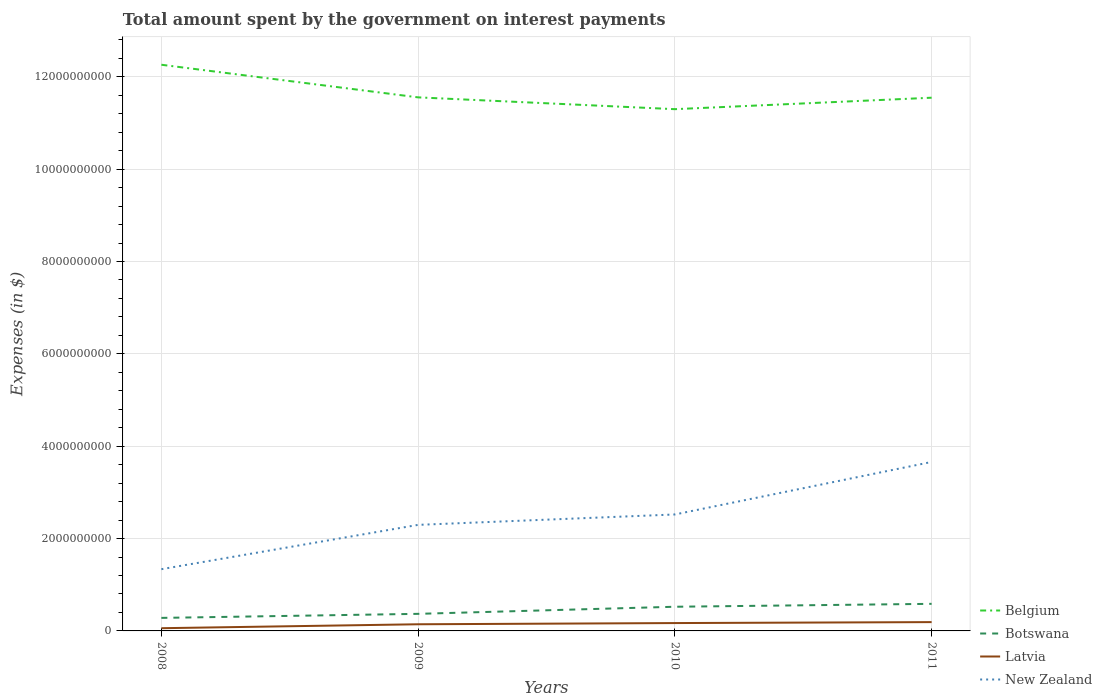How many different coloured lines are there?
Make the answer very short. 4. Across all years, what is the maximum amount spent on interest payments by the government in New Zealand?
Keep it short and to the point. 1.34e+09. What is the total amount spent on interest payments by the government in New Zealand in the graph?
Make the answer very short. -1.36e+09. What is the difference between the highest and the second highest amount spent on interest payments by the government in Latvia?
Offer a terse response. 1.32e+08. What is the difference between the highest and the lowest amount spent on interest payments by the government in Botswana?
Make the answer very short. 2. Is the amount spent on interest payments by the government in New Zealand strictly greater than the amount spent on interest payments by the government in Botswana over the years?
Provide a short and direct response. No. How many lines are there?
Ensure brevity in your answer.  4. Does the graph contain any zero values?
Offer a terse response. No. What is the title of the graph?
Offer a terse response. Total amount spent by the government on interest payments. Does "Maldives" appear as one of the legend labels in the graph?
Your answer should be very brief. No. What is the label or title of the X-axis?
Give a very brief answer. Years. What is the label or title of the Y-axis?
Your response must be concise. Expenses (in $). What is the Expenses (in $) of Belgium in 2008?
Offer a very short reply. 1.23e+1. What is the Expenses (in $) in Botswana in 2008?
Provide a succinct answer. 2.82e+08. What is the Expenses (in $) in Latvia in 2008?
Your response must be concise. 5.90e+07. What is the Expenses (in $) in New Zealand in 2008?
Give a very brief answer. 1.34e+09. What is the Expenses (in $) in Belgium in 2009?
Your answer should be compact. 1.16e+1. What is the Expenses (in $) in Botswana in 2009?
Offer a very short reply. 3.70e+08. What is the Expenses (in $) of Latvia in 2009?
Offer a terse response. 1.44e+08. What is the Expenses (in $) in New Zealand in 2009?
Provide a short and direct response. 2.30e+09. What is the Expenses (in $) of Belgium in 2010?
Give a very brief answer. 1.13e+1. What is the Expenses (in $) in Botswana in 2010?
Give a very brief answer. 5.24e+08. What is the Expenses (in $) of Latvia in 2010?
Give a very brief answer. 1.70e+08. What is the Expenses (in $) in New Zealand in 2010?
Ensure brevity in your answer.  2.52e+09. What is the Expenses (in $) in Belgium in 2011?
Your answer should be compact. 1.15e+1. What is the Expenses (in $) in Botswana in 2011?
Your response must be concise. 5.87e+08. What is the Expenses (in $) of Latvia in 2011?
Provide a short and direct response. 1.91e+08. What is the Expenses (in $) of New Zealand in 2011?
Give a very brief answer. 3.66e+09. Across all years, what is the maximum Expenses (in $) of Belgium?
Provide a short and direct response. 1.23e+1. Across all years, what is the maximum Expenses (in $) in Botswana?
Offer a very short reply. 5.87e+08. Across all years, what is the maximum Expenses (in $) of Latvia?
Make the answer very short. 1.91e+08. Across all years, what is the maximum Expenses (in $) of New Zealand?
Make the answer very short. 3.66e+09. Across all years, what is the minimum Expenses (in $) of Belgium?
Provide a short and direct response. 1.13e+1. Across all years, what is the minimum Expenses (in $) in Botswana?
Your response must be concise. 2.82e+08. Across all years, what is the minimum Expenses (in $) of Latvia?
Offer a very short reply. 5.90e+07. Across all years, what is the minimum Expenses (in $) in New Zealand?
Give a very brief answer. 1.34e+09. What is the total Expenses (in $) in Belgium in the graph?
Your answer should be compact. 4.67e+1. What is the total Expenses (in $) of Botswana in the graph?
Your answer should be compact. 1.76e+09. What is the total Expenses (in $) in Latvia in the graph?
Provide a short and direct response. 5.64e+08. What is the total Expenses (in $) in New Zealand in the graph?
Offer a very short reply. 9.81e+09. What is the difference between the Expenses (in $) in Belgium in 2008 and that in 2009?
Your answer should be very brief. 7.06e+08. What is the difference between the Expenses (in $) of Botswana in 2008 and that in 2009?
Make the answer very short. -8.77e+07. What is the difference between the Expenses (in $) of Latvia in 2008 and that in 2009?
Offer a very short reply. -8.50e+07. What is the difference between the Expenses (in $) of New Zealand in 2008 and that in 2009?
Your answer should be compact. -9.60e+08. What is the difference between the Expenses (in $) in Belgium in 2008 and that in 2010?
Your answer should be compact. 9.62e+08. What is the difference between the Expenses (in $) in Botswana in 2008 and that in 2010?
Offer a terse response. -2.41e+08. What is the difference between the Expenses (in $) of Latvia in 2008 and that in 2010?
Provide a short and direct response. -1.11e+08. What is the difference between the Expenses (in $) in New Zealand in 2008 and that in 2010?
Keep it short and to the point. -1.18e+09. What is the difference between the Expenses (in $) of Belgium in 2008 and that in 2011?
Ensure brevity in your answer.  7.14e+08. What is the difference between the Expenses (in $) of Botswana in 2008 and that in 2011?
Your answer should be very brief. -3.04e+08. What is the difference between the Expenses (in $) in Latvia in 2008 and that in 2011?
Provide a short and direct response. -1.32e+08. What is the difference between the Expenses (in $) in New Zealand in 2008 and that in 2011?
Offer a terse response. -2.32e+09. What is the difference between the Expenses (in $) in Belgium in 2009 and that in 2010?
Your response must be concise. 2.56e+08. What is the difference between the Expenses (in $) of Botswana in 2009 and that in 2010?
Keep it short and to the point. -1.54e+08. What is the difference between the Expenses (in $) of Latvia in 2009 and that in 2010?
Your answer should be compact. -2.62e+07. What is the difference between the Expenses (in $) in New Zealand in 2009 and that in 2010?
Offer a very short reply. -2.25e+08. What is the difference between the Expenses (in $) of Belgium in 2009 and that in 2011?
Offer a very short reply. 7.50e+06. What is the difference between the Expenses (in $) in Botswana in 2009 and that in 2011?
Offer a terse response. -2.17e+08. What is the difference between the Expenses (in $) of Latvia in 2009 and that in 2011?
Ensure brevity in your answer.  -4.69e+07. What is the difference between the Expenses (in $) in New Zealand in 2009 and that in 2011?
Ensure brevity in your answer.  -1.36e+09. What is the difference between the Expenses (in $) in Belgium in 2010 and that in 2011?
Offer a very short reply. -2.48e+08. What is the difference between the Expenses (in $) of Botswana in 2010 and that in 2011?
Provide a succinct answer. -6.30e+07. What is the difference between the Expenses (in $) of Latvia in 2010 and that in 2011?
Your answer should be compact. -2.07e+07. What is the difference between the Expenses (in $) in New Zealand in 2010 and that in 2011?
Your response must be concise. -1.14e+09. What is the difference between the Expenses (in $) of Belgium in 2008 and the Expenses (in $) of Botswana in 2009?
Provide a succinct answer. 1.19e+1. What is the difference between the Expenses (in $) of Belgium in 2008 and the Expenses (in $) of Latvia in 2009?
Your response must be concise. 1.21e+1. What is the difference between the Expenses (in $) in Belgium in 2008 and the Expenses (in $) in New Zealand in 2009?
Your answer should be very brief. 9.96e+09. What is the difference between the Expenses (in $) in Botswana in 2008 and the Expenses (in $) in Latvia in 2009?
Provide a succinct answer. 1.38e+08. What is the difference between the Expenses (in $) in Botswana in 2008 and the Expenses (in $) in New Zealand in 2009?
Your answer should be very brief. -2.01e+09. What is the difference between the Expenses (in $) of Latvia in 2008 and the Expenses (in $) of New Zealand in 2009?
Provide a succinct answer. -2.24e+09. What is the difference between the Expenses (in $) in Belgium in 2008 and the Expenses (in $) in Botswana in 2010?
Make the answer very short. 1.17e+1. What is the difference between the Expenses (in $) in Belgium in 2008 and the Expenses (in $) in Latvia in 2010?
Offer a terse response. 1.21e+1. What is the difference between the Expenses (in $) of Belgium in 2008 and the Expenses (in $) of New Zealand in 2010?
Your answer should be compact. 9.74e+09. What is the difference between the Expenses (in $) in Botswana in 2008 and the Expenses (in $) in Latvia in 2010?
Provide a short and direct response. 1.12e+08. What is the difference between the Expenses (in $) in Botswana in 2008 and the Expenses (in $) in New Zealand in 2010?
Your answer should be very brief. -2.24e+09. What is the difference between the Expenses (in $) in Latvia in 2008 and the Expenses (in $) in New Zealand in 2010?
Your response must be concise. -2.46e+09. What is the difference between the Expenses (in $) of Belgium in 2008 and the Expenses (in $) of Botswana in 2011?
Make the answer very short. 1.17e+1. What is the difference between the Expenses (in $) of Belgium in 2008 and the Expenses (in $) of Latvia in 2011?
Make the answer very short. 1.21e+1. What is the difference between the Expenses (in $) in Belgium in 2008 and the Expenses (in $) in New Zealand in 2011?
Ensure brevity in your answer.  8.60e+09. What is the difference between the Expenses (in $) of Botswana in 2008 and the Expenses (in $) of Latvia in 2011?
Your answer should be very brief. 9.11e+07. What is the difference between the Expenses (in $) in Botswana in 2008 and the Expenses (in $) in New Zealand in 2011?
Provide a succinct answer. -3.38e+09. What is the difference between the Expenses (in $) of Latvia in 2008 and the Expenses (in $) of New Zealand in 2011?
Your response must be concise. -3.60e+09. What is the difference between the Expenses (in $) of Belgium in 2009 and the Expenses (in $) of Botswana in 2010?
Provide a succinct answer. 1.10e+1. What is the difference between the Expenses (in $) in Belgium in 2009 and the Expenses (in $) in Latvia in 2010?
Offer a very short reply. 1.14e+1. What is the difference between the Expenses (in $) in Belgium in 2009 and the Expenses (in $) in New Zealand in 2010?
Provide a succinct answer. 9.03e+09. What is the difference between the Expenses (in $) of Botswana in 2009 and the Expenses (in $) of Latvia in 2010?
Provide a short and direct response. 2.00e+08. What is the difference between the Expenses (in $) in Botswana in 2009 and the Expenses (in $) in New Zealand in 2010?
Provide a succinct answer. -2.15e+09. What is the difference between the Expenses (in $) in Latvia in 2009 and the Expenses (in $) in New Zealand in 2010?
Ensure brevity in your answer.  -2.38e+09. What is the difference between the Expenses (in $) of Belgium in 2009 and the Expenses (in $) of Botswana in 2011?
Offer a very short reply. 1.10e+1. What is the difference between the Expenses (in $) in Belgium in 2009 and the Expenses (in $) in Latvia in 2011?
Ensure brevity in your answer.  1.14e+1. What is the difference between the Expenses (in $) in Belgium in 2009 and the Expenses (in $) in New Zealand in 2011?
Your answer should be compact. 7.90e+09. What is the difference between the Expenses (in $) in Botswana in 2009 and the Expenses (in $) in Latvia in 2011?
Keep it short and to the point. 1.79e+08. What is the difference between the Expenses (in $) in Botswana in 2009 and the Expenses (in $) in New Zealand in 2011?
Ensure brevity in your answer.  -3.29e+09. What is the difference between the Expenses (in $) in Latvia in 2009 and the Expenses (in $) in New Zealand in 2011?
Provide a short and direct response. -3.52e+09. What is the difference between the Expenses (in $) of Belgium in 2010 and the Expenses (in $) of Botswana in 2011?
Make the answer very short. 1.07e+1. What is the difference between the Expenses (in $) of Belgium in 2010 and the Expenses (in $) of Latvia in 2011?
Provide a succinct answer. 1.11e+1. What is the difference between the Expenses (in $) in Belgium in 2010 and the Expenses (in $) in New Zealand in 2011?
Ensure brevity in your answer.  7.64e+09. What is the difference between the Expenses (in $) in Botswana in 2010 and the Expenses (in $) in Latvia in 2011?
Give a very brief answer. 3.33e+08. What is the difference between the Expenses (in $) of Botswana in 2010 and the Expenses (in $) of New Zealand in 2011?
Your response must be concise. -3.14e+09. What is the difference between the Expenses (in $) of Latvia in 2010 and the Expenses (in $) of New Zealand in 2011?
Your answer should be very brief. -3.49e+09. What is the average Expenses (in $) in Belgium per year?
Make the answer very short. 1.17e+1. What is the average Expenses (in $) in Botswana per year?
Offer a very short reply. 4.41e+08. What is the average Expenses (in $) in Latvia per year?
Your response must be concise. 1.41e+08. What is the average Expenses (in $) of New Zealand per year?
Ensure brevity in your answer.  2.45e+09. In the year 2008, what is the difference between the Expenses (in $) of Belgium and Expenses (in $) of Botswana?
Keep it short and to the point. 1.20e+1. In the year 2008, what is the difference between the Expenses (in $) in Belgium and Expenses (in $) in Latvia?
Ensure brevity in your answer.  1.22e+1. In the year 2008, what is the difference between the Expenses (in $) in Belgium and Expenses (in $) in New Zealand?
Provide a short and direct response. 1.09e+1. In the year 2008, what is the difference between the Expenses (in $) in Botswana and Expenses (in $) in Latvia?
Your answer should be compact. 2.23e+08. In the year 2008, what is the difference between the Expenses (in $) in Botswana and Expenses (in $) in New Zealand?
Keep it short and to the point. -1.05e+09. In the year 2008, what is the difference between the Expenses (in $) of Latvia and Expenses (in $) of New Zealand?
Provide a succinct answer. -1.28e+09. In the year 2009, what is the difference between the Expenses (in $) in Belgium and Expenses (in $) in Botswana?
Your response must be concise. 1.12e+1. In the year 2009, what is the difference between the Expenses (in $) in Belgium and Expenses (in $) in Latvia?
Your response must be concise. 1.14e+1. In the year 2009, what is the difference between the Expenses (in $) in Belgium and Expenses (in $) in New Zealand?
Offer a very short reply. 9.26e+09. In the year 2009, what is the difference between the Expenses (in $) of Botswana and Expenses (in $) of Latvia?
Keep it short and to the point. 2.26e+08. In the year 2009, what is the difference between the Expenses (in $) in Botswana and Expenses (in $) in New Zealand?
Ensure brevity in your answer.  -1.93e+09. In the year 2009, what is the difference between the Expenses (in $) of Latvia and Expenses (in $) of New Zealand?
Offer a very short reply. -2.15e+09. In the year 2010, what is the difference between the Expenses (in $) in Belgium and Expenses (in $) in Botswana?
Give a very brief answer. 1.08e+1. In the year 2010, what is the difference between the Expenses (in $) in Belgium and Expenses (in $) in Latvia?
Your answer should be very brief. 1.11e+1. In the year 2010, what is the difference between the Expenses (in $) in Belgium and Expenses (in $) in New Zealand?
Your answer should be compact. 8.78e+09. In the year 2010, what is the difference between the Expenses (in $) in Botswana and Expenses (in $) in Latvia?
Your answer should be compact. 3.53e+08. In the year 2010, what is the difference between the Expenses (in $) in Botswana and Expenses (in $) in New Zealand?
Your answer should be very brief. -2.00e+09. In the year 2010, what is the difference between the Expenses (in $) of Latvia and Expenses (in $) of New Zealand?
Offer a very short reply. -2.35e+09. In the year 2011, what is the difference between the Expenses (in $) in Belgium and Expenses (in $) in Botswana?
Provide a short and direct response. 1.10e+1. In the year 2011, what is the difference between the Expenses (in $) in Belgium and Expenses (in $) in Latvia?
Provide a short and direct response. 1.14e+1. In the year 2011, what is the difference between the Expenses (in $) of Belgium and Expenses (in $) of New Zealand?
Provide a succinct answer. 7.89e+09. In the year 2011, what is the difference between the Expenses (in $) of Botswana and Expenses (in $) of Latvia?
Your response must be concise. 3.96e+08. In the year 2011, what is the difference between the Expenses (in $) in Botswana and Expenses (in $) in New Zealand?
Keep it short and to the point. -3.07e+09. In the year 2011, what is the difference between the Expenses (in $) in Latvia and Expenses (in $) in New Zealand?
Your answer should be very brief. -3.47e+09. What is the ratio of the Expenses (in $) of Belgium in 2008 to that in 2009?
Offer a terse response. 1.06. What is the ratio of the Expenses (in $) in Botswana in 2008 to that in 2009?
Your answer should be compact. 0.76. What is the ratio of the Expenses (in $) of Latvia in 2008 to that in 2009?
Provide a succinct answer. 0.41. What is the ratio of the Expenses (in $) of New Zealand in 2008 to that in 2009?
Your response must be concise. 0.58. What is the ratio of the Expenses (in $) in Belgium in 2008 to that in 2010?
Make the answer very short. 1.09. What is the ratio of the Expenses (in $) of Botswana in 2008 to that in 2010?
Keep it short and to the point. 0.54. What is the ratio of the Expenses (in $) in Latvia in 2008 to that in 2010?
Your answer should be compact. 0.35. What is the ratio of the Expenses (in $) in New Zealand in 2008 to that in 2010?
Your answer should be compact. 0.53. What is the ratio of the Expenses (in $) in Belgium in 2008 to that in 2011?
Offer a very short reply. 1.06. What is the ratio of the Expenses (in $) of Botswana in 2008 to that in 2011?
Offer a very short reply. 0.48. What is the ratio of the Expenses (in $) of Latvia in 2008 to that in 2011?
Keep it short and to the point. 0.31. What is the ratio of the Expenses (in $) in New Zealand in 2008 to that in 2011?
Provide a succinct answer. 0.37. What is the ratio of the Expenses (in $) of Belgium in 2009 to that in 2010?
Offer a terse response. 1.02. What is the ratio of the Expenses (in $) of Botswana in 2009 to that in 2010?
Offer a very short reply. 0.71. What is the ratio of the Expenses (in $) of Latvia in 2009 to that in 2010?
Give a very brief answer. 0.85. What is the ratio of the Expenses (in $) in New Zealand in 2009 to that in 2010?
Provide a short and direct response. 0.91. What is the ratio of the Expenses (in $) in Belgium in 2009 to that in 2011?
Make the answer very short. 1. What is the ratio of the Expenses (in $) in Botswana in 2009 to that in 2011?
Ensure brevity in your answer.  0.63. What is the ratio of the Expenses (in $) of Latvia in 2009 to that in 2011?
Offer a very short reply. 0.75. What is the ratio of the Expenses (in $) of New Zealand in 2009 to that in 2011?
Provide a succinct answer. 0.63. What is the ratio of the Expenses (in $) of Belgium in 2010 to that in 2011?
Offer a terse response. 0.98. What is the ratio of the Expenses (in $) in Botswana in 2010 to that in 2011?
Your answer should be very brief. 0.89. What is the ratio of the Expenses (in $) of Latvia in 2010 to that in 2011?
Keep it short and to the point. 0.89. What is the ratio of the Expenses (in $) of New Zealand in 2010 to that in 2011?
Your response must be concise. 0.69. What is the difference between the highest and the second highest Expenses (in $) of Belgium?
Provide a succinct answer. 7.06e+08. What is the difference between the highest and the second highest Expenses (in $) of Botswana?
Offer a terse response. 6.30e+07. What is the difference between the highest and the second highest Expenses (in $) in Latvia?
Your answer should be very brief. 2.07e+07. What is the difference between the highest and the second highest Expenses (in $) in New Zealand?
Your answer should be very brief. 1.14e+09. What is the difference between the highest and the lowest Expenses (in $) in Belgium?
Offer a very short reply. 9.62e+08. What is the difference between the highest and the lowest Expenses (in $) in Botswana?
Your response must be concise. 3.04e+08. What is the difference between the highest and the lowest Expenses (in $) of Latvia?
Make the answer very short. 1.32e+08. What is the difference between the highest and the lowest Expenses (in $) of New Zealand?
Offer a terse response. 2.32e+09. 